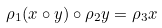Convert formula to latex. <formula><loc_0><loc_0><loc_500><loc_500>\rho _ { 1 } ( x \circ y ) \circ \rho _ { 2 } y = \rho _ { 3 } x</formula> 